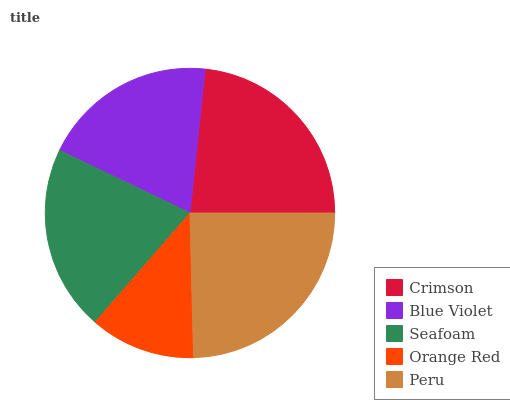Is Orange Red the minimum?
Answer yes or no. Yes. Is Peru the maximum?
Answer yes or no. Yes. Is Blue Violet the minimum?
Answer yes or no. No. Is Blue Violet the maximum?
Answer yes or no. No. Is Crimson greater than Blue Violet?
Answer yes or no. Yes. Is Blue Violet less than Crimson?
Answer yes or no. Yes. Is Blue Violet greater than Crimson?
Answer yes or no. No. Is Crimson less than Blue Violet?
Answer yes or no. No. Is Seafoam the high median?
Answer yes or no. Yes. Is Seafoam the low median?
Answer yes or no. Yes. Is Crimson the high median?
Answer yes or no. No. Is Blue Violet the low median?
Answer yes or no. No. 